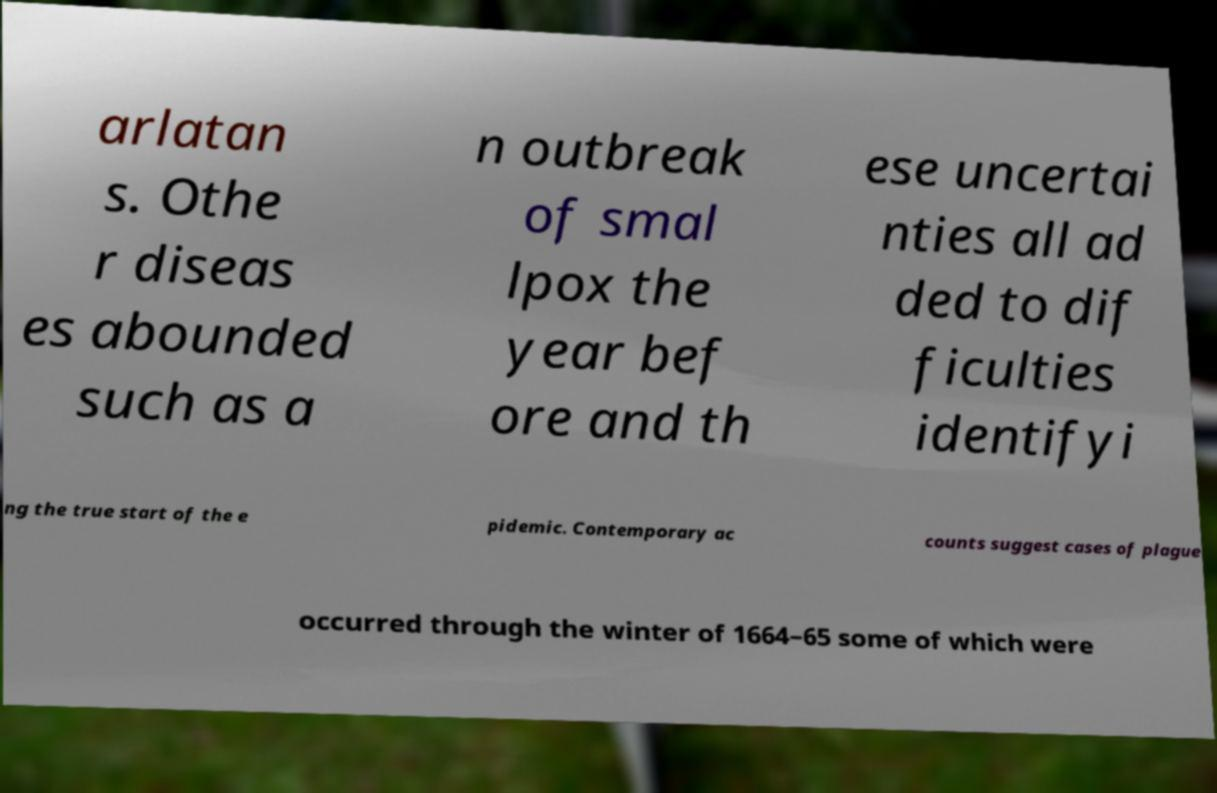What messages or text are displayed in this image? I need them in a readable, typed format. arlatan s. Othe r diseas es abounded such as a n outbreak of smal lpox the year bef ore and th ese uncertai nties all ad ded to dif ficulties identifyi ng the true start of the e pidemic. Contemporary ac counts suggest cases of plague occurred through the winter of 1664–65 some of which were 